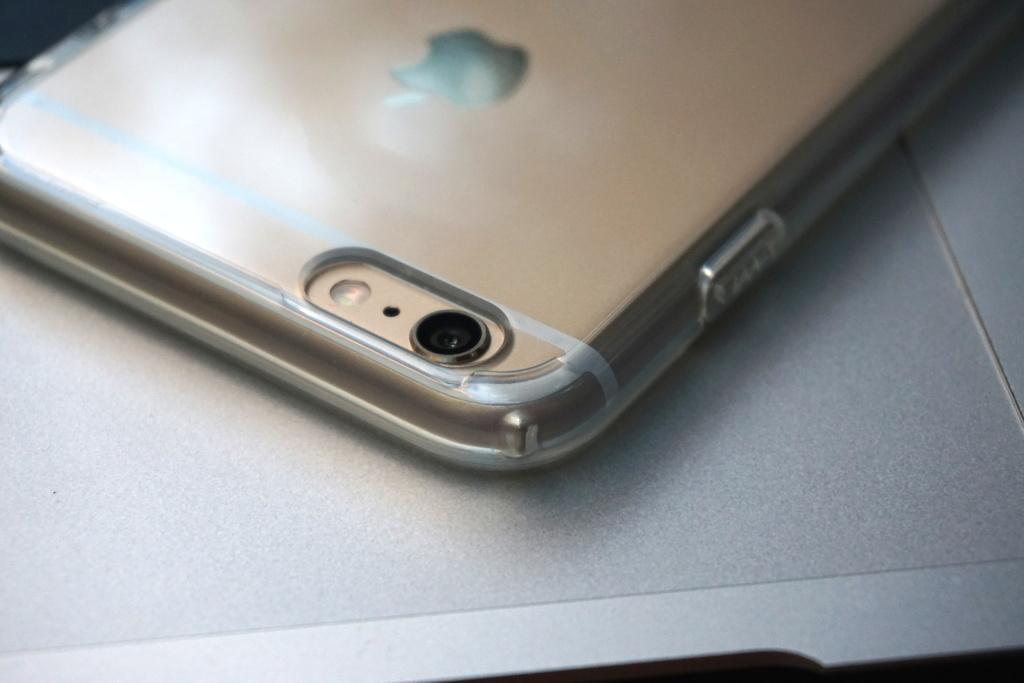What object is visible in the image? There is a mobile phone in the image. Where is the mobile phone located? The mobile phone is placed on a table. How deep is the sea in the image? There is no sea present in the image; it only features a mobile phone placed on a table. 